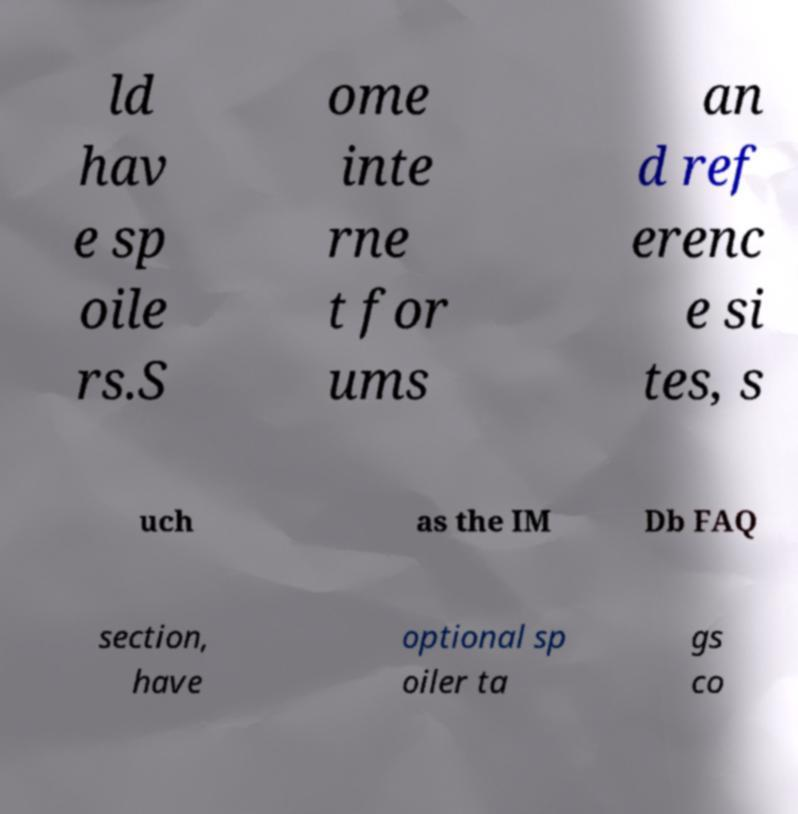Please identify and transcribe the text found in this image. ld hav e sp oile rs.S ome inte rne t for ums an d ref erenc e si tes, s uch as the IM Db FAQ section, have optional sp oiler ta gs co 